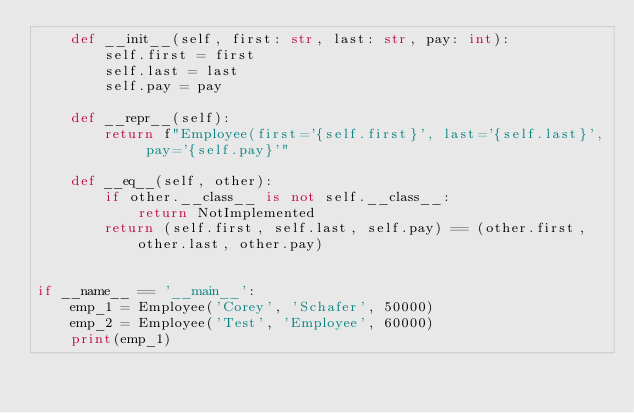Convert code to text. <code><loc_0><loc_0><loc_500><loc_500><_Python_>    def __init__(self, first: str, last: str, pay: int):
        self.first = first
        self.last = last
        self.pay = pay

    def __repr__(self):
        return f"Employee(first='{self.first}', last='{self.last}', pay='{self.pay}'"

    def __eq__(self, other):
        if other.__class__ is not self.__class__:
            return NotImplemented
        return (self.first, self.last, self.pay) == (other.first, other.last, other.pay)


if __name__ == '__main__':
    emp_1 = Employee('Corey', 'Schafer', 50000)
    emp_2 = Employee('Test', 'Employee', 60000)
    print(emp_1)
</code> 